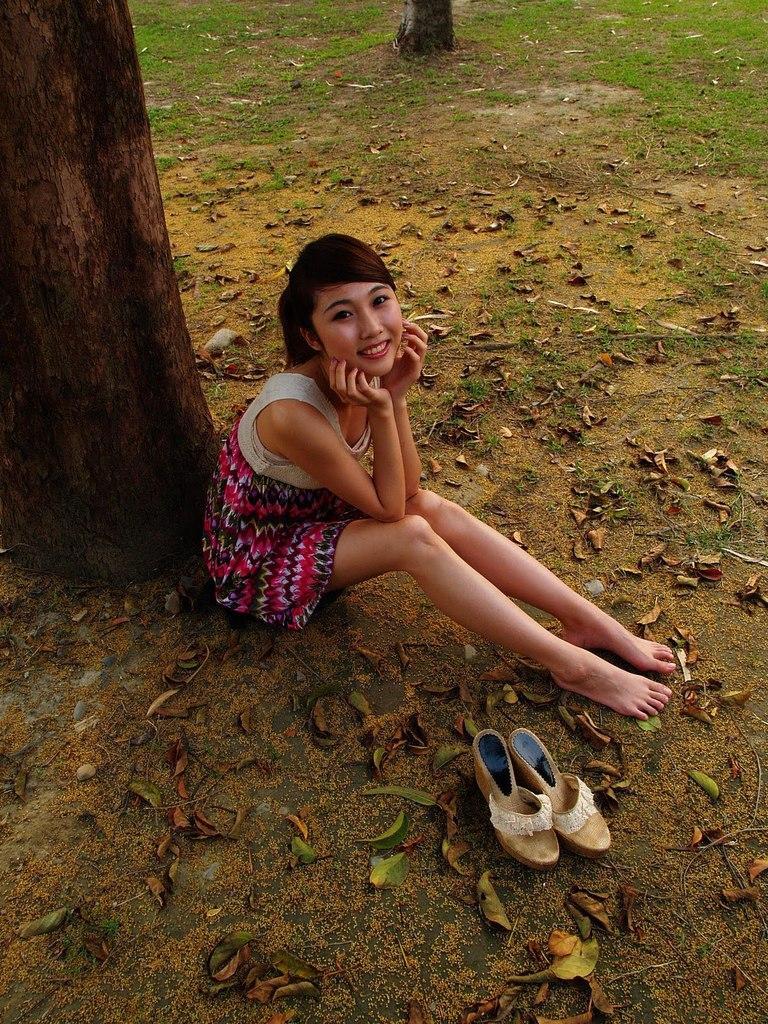Please provide a concise description of this image. In this image there is a woman sitting on the surface, beside the women there are a pair of sandals, behind the woman there is a trunk of a tree, at the top of the image there is another trunk of a tree, on the surface there are dry leaves. 